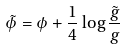<formula> <loc_0><loc_0><loc_500><loc_500>\tilde { \phi } = \phi + \frac { 1 } { 4 } \log \frac { \tilde { g } } { g }</formula> 